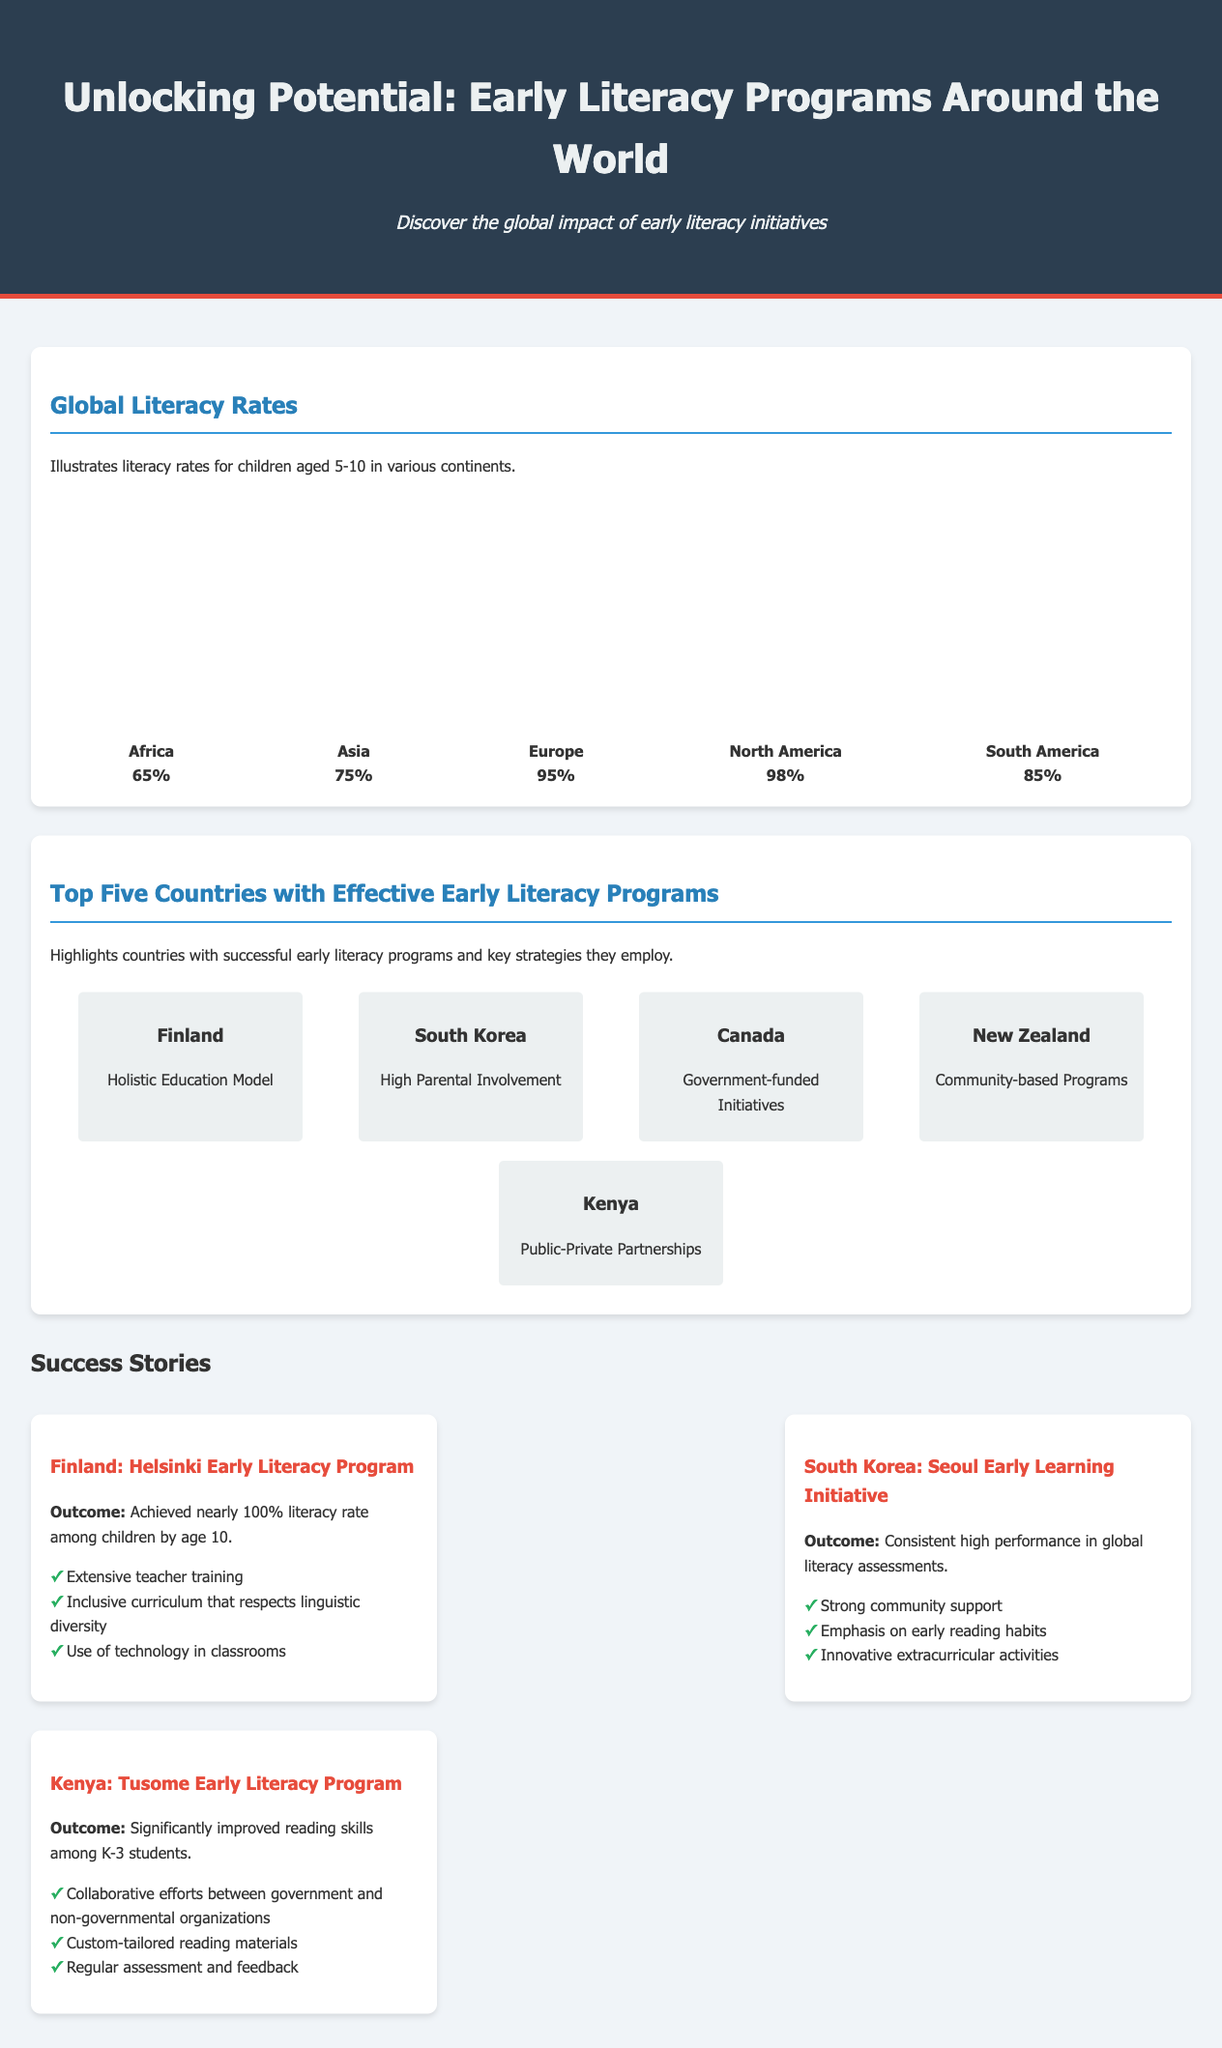What is the literacy rate for Africa? The document states the literacy rate for children aged 5-10 in Africa as 65%.
Answer: 65% Which country is noted for its Holistic Education Model? The country highlighted for its holistic education model is Finland.
Answer: Finland What is the outcome of the Helsinki Early Literacy Program? The document notes that this program achieved nearly 100% literacy rate among children by age 10.
Answer: Nearly 100% How many countries are highlighted as having effective early literacy programs? The infographic indicates there are five countries highlighted for their effective programs.
Answer: Five What key strategy is attributed to Canada's early literacy programs? The document mentions that Canada's programs are supported by government-funded initiatives.
Answer: Government-funded Initiatives What percentage of literacy is reported for North America? The literacy rate for North America is reported as 98%.
Answer: 98% Which country achieved significantly improved reading skills among K-3 students? The document highlights that Kenya's Tusome Early Literacy Program significantly improved reading skills.
Answer: Kenya What common characteristic is noted in the success stories of Finland and South Korea? Both countries emphasize strong community and parental involvement in their early literacy programs.
Answer: Community involvement 